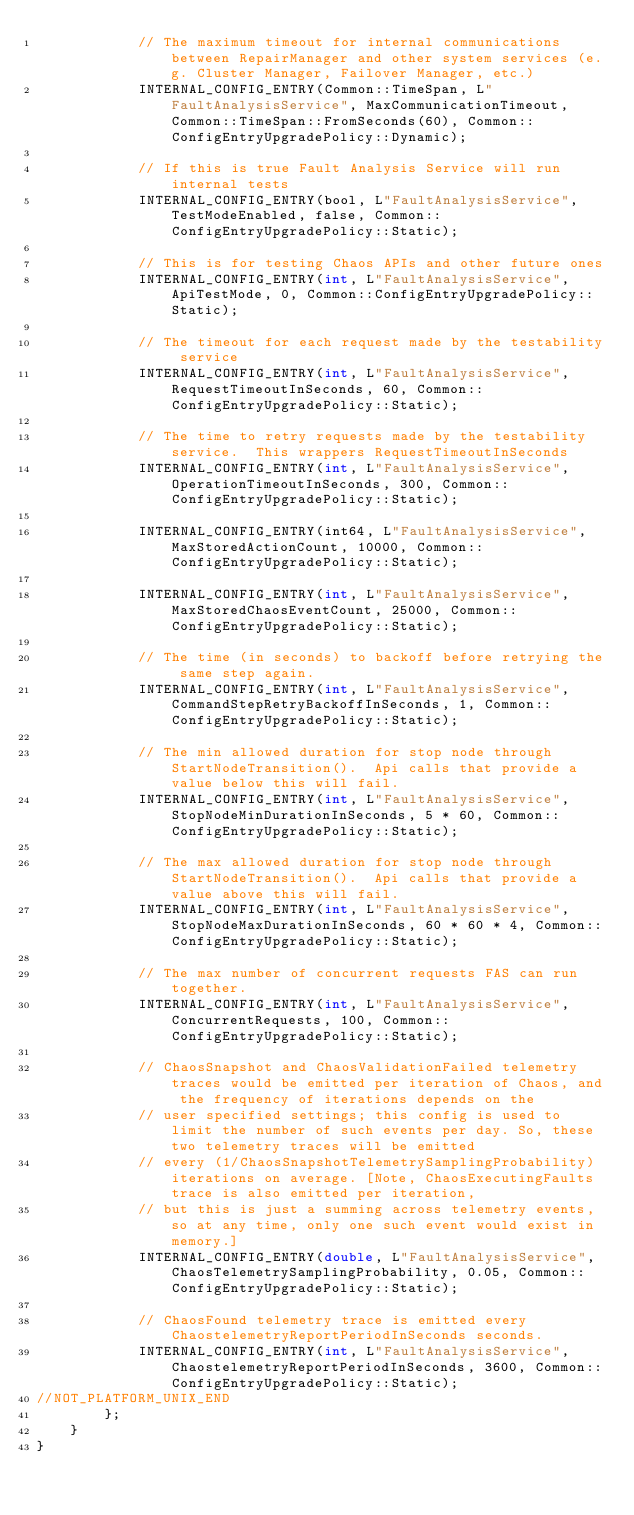Convert code to text. <code><loc_0><loc_0><loc_500><loc_500><_C_>            // The maximum timeout for internal communications between RepairManager and other system services (e.g. Cluster Manager, Failover Manager, etc.)
            INTERNAL_CONFIG_ENTRY(Common::TimeSpan, L"FaultAnalysisService", MaxCommunicationTimeout, Common::TimeSpan::FromSeconds(60), Common::ConfigEntryUpgradePolicy::Dynamic);

            // If this is true Fault Analysis Service will run internal tests
            INTERNAL_CONFIG_ENTRY(bool, L"FaultAnalysisService", TestModeEnabled, false, Common::ConfigEntryUpgradePolicy::Static);

            // This is for testing Chaos APIs and other future ones
            INTERNAL_CONFIG_ENTRY(int, L"FaultAnalysisService", ApiTestMode, 0, Common::ConfigEntryUpgradePolicy::Static);

            // The timeout for each request made by the testability service
            INTERNAL_CONFIG_ENTRY(int, L"FaultAnalysisService", RequestTimeoutInSeconds, 60, Common::ConfigEntryUpgradePolicy::Static);

            // The time to retry requests made by the testability service.  This wrappers RequestTimeoutInSeconds
            INTERNAL_CONFIG_ENTRY(int, L"FaultAnalysisService", OperationTimeoutInSeconds, 300, Common::ConfigEntryUpgradePolicy::Static);

            INTERNAL_CONFIG_ENTRY(int64, L"FaultAnalysisService", MaxStoredActionCount, 10000, Common::ConfigEntryUpgradePolicy::Static);

            INTERNAL_CONFIG_ENTRY(int, L"FaultAnalysisService", MaxStoredChaosEventCount, 25000, Common::ConfigEntryUpgradePolicy::Static);

            // The time (in seconds) to backoff before retrying the same step again.
            INTERNAL_CONFIG_ENTRY(int, L"FaultAnalysisService", CommandStepRetryBackoffInSeconds, 1, Common::ConfigEntryUpgradePolicy::Static);

            // The min allowed duration for stop node through StartNodeTransition().  Api calls that provide a value below this will fail.
            INTERNAL_CONFIG_ENTRY(int, L"FaultAnalysisService", StopNodeMinDurationInSeconds, 5 * 60, Common::ConfigEntryUpgradePolicy::Static);

            // The max allowed duration for stop node through StartNodeTransition().  Api calls that provide a value above this will fail.
            INTERNAL_CONFIG_ENTRY(int, L"FaultAnalysisService", StopNodeMaxDurationInSeconds, 60 * 60 * 4, Common::ConfigEntryUpgradePolicy::Static);

            // The max number of concurrent requests FAS can run together.
            INTERNAL_CONFIG_ENTRY(int, L"FaultAnalysisService", ConcurrentRequests, 100, Common::ConfigEntryUpgradePolicy::Static);

            // ChaosSnapshot and ChaosValidationFailed telemetry traces would be emitted per iteration of Chaos, and the frequency of iterations depends on the
            // user specified settings; this config is used to limit the number of such events per day. So, these two telemetry traces will be emitted
            // every (1/ChaosSnapshotTelemetrySamplingProbability) iterations on average. [Note, ChaosExecutingFaults trace is also emitted per iteration, 
            // but this is just a summing across telemetry events, so at any time, only one such event would exist in memory.]
            INTERNAL_CONFIG_ENTRY(double, L"FaultAnalysisService", ChaosTelemetrySamplingProbability, 0.05, Common::ConfigEntryUpgradePolicy::Static);

            // ChaosFound telemetry trace is emitted every ChaostelemetryReportPeriodInSeconds seconds.
            INTERNAL_CONFIG_ENTRY(int, L"FaultAnalysisService", ChaostelemetryReportPeriodInSeconds, 3600, Common::ConfigEntryUpgradePolicy::Static);
//NOT_PLATFORM_UNIX_END
        };
    }
}
</code> 